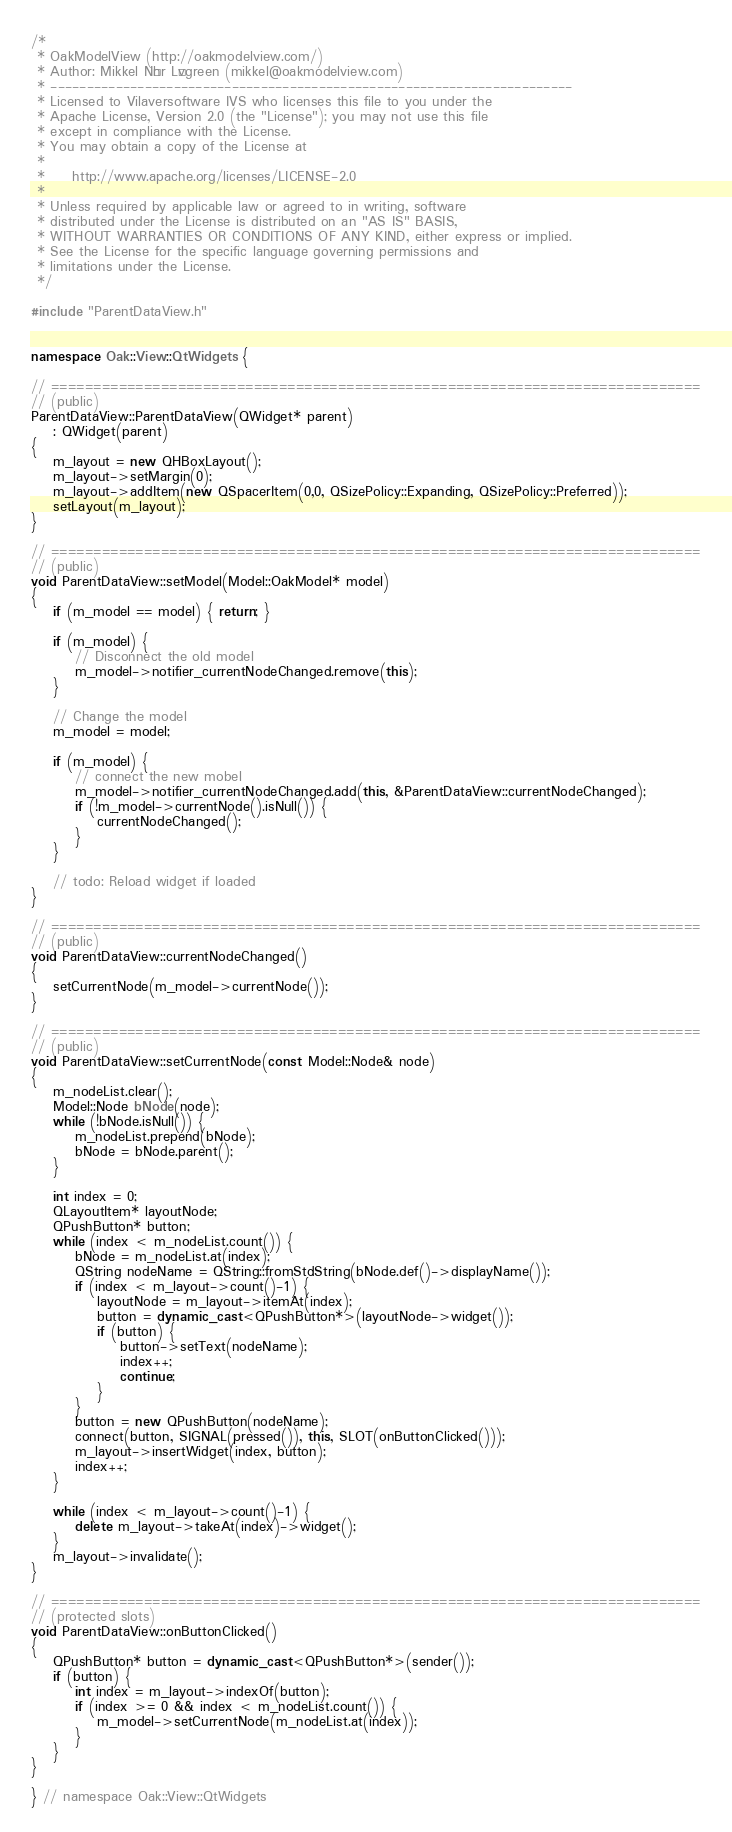<code> <loc_0><loc_0><loc_500><loc_500><_C++_>/*
 * OakModelView (http://oakmodelview.com/)
 * Author: Mikkel Nøhr Løvgreen (mikkel@oakmodelview.com)
 * ------------------------------------------------------------------------
 * Licensed to Vilaversoftware IVS who licenses this file to you under the
 * Apache License, Version 2.0 (the "License"); you may not use this file
 * except in compliance with the License.
 * You may obtain a copy of the License at
 *
 *     http://www.apache.org/licenses/LICENSE-2.0
 *
 * Unless required by applicable law or agreed to in writing, software
 * distributed under the License is distributed on an "AS IS" BASIS,
 * WITHOUT WARRANTIES OR CONDITIONS OF ANY KIND, either express or implied.
 * See the License for the specific language governing permissions and
 * limitations under the License.
 */

#include "ParentDataView.h"


namespace Oak::View::QtWidgets {

// =============================================================================
// (public)
ParentDataView::ParentDataView(QWidget* parent)
    : QWidget(parent)
{
    m_layout = new QHBoxLayout();
    m_layout->setMargin(0);
    m_layout->addItem(new QSpacerItem(0,0, QSizePolicy::Expanding, QSizePolicy::Preferred));
    setLayout(m_layout);
}

// =============================================================================
// (public)
void ParentDataView::setModel(Model::OakModel* model)
{
    if (m_model == model) { return; }

    if (m_model) {
        // Disconnect the old model
        m_model->notifier_currentNodeChanged.remove(this);
    }

    // Change the model
    m_model = model;

    if (m_model) {
        // connect the new mobel
        m_model->notifier_currentNodeChanged.add(this, &ParentDataView::currentNodeChanged);
        if (!m_model->currentNode().isNull()) {
            currentNodeChanged();
        }
    }

    // todo: Reload widget if loaded
}

// =============================================================================
// (public)
void ParentDataView::currentNodeChanged()
{
    setCurrentNode(m_model->currentNode());
}

// =============================================================================
// (public)
void ParentDataView::setCurrentNode(const Model::Node& node)
{
    m_nodeList.clear();
    Model::Node bNode(node);
    while (!bNode.isNull()) {
        m_nodeList.prepend(bNode);
        bNode = bNode.parent();
    }

    int index = 0;
    QLayoutItem* layoutNode;
    QPushButton* button;
    while (index < m_nodeList.count()) {
        bNode = m_nodeList.at(index);
        QString nodeName = QString::fromStdString(bNode.def()->displayName());
        if (index < m_layout->count()-1) {
            layoutNode = m_layout->itemAt(index);
            button = dynamic_cast<QPushButton*>(layoutNode->widget());
            if (button) {
                button->setText(nodeName);
                index++;
                continue;
            }
        }
        button = new QPushButton(nodeName);
        connect(button, SIGNAL(pressed()), this, SLOT(onButtonClicked()));
        m_layout->insertWidget(index, button);
        index++;
    }

    while (index < m_layout->count()-1) {
        delete m_layout->takeAt(index)->widget();
    }
    m_layout->invalidate();
}

// =============================================================================
// (protected slots)
void ParentDataView::onButtonClicked()
{
    QPushButton* button = dynamic_cast<QPushButton*>(sender());
    if (button) {
        int index = m_layout->indexOf(button);
        if (index >= 0 && index < m_nodeList.count()) {
            m_model->setCurrentNode(m_nodeList.at(index));
        }
    }
}

} // namespace Oak::View::QtWidgets

</code> 